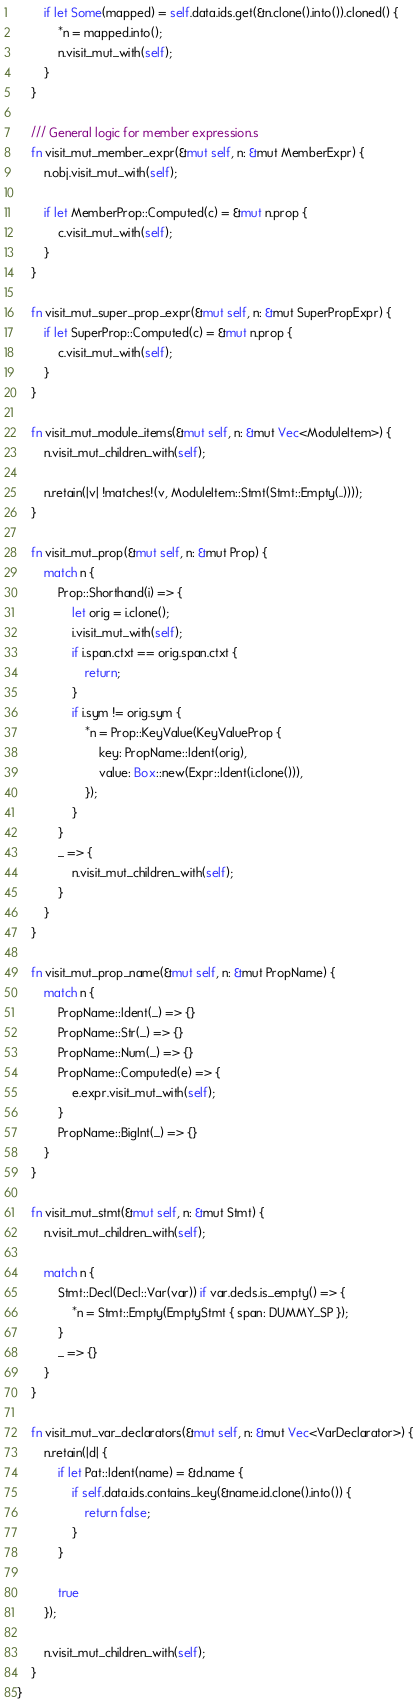<code> <loc_0><loc_0><loc_500><loc_500><_Rust_>        if let Some(mapped) = self.data.ids.get(&n.clone().into()).cloned() {
            *n = mapped.into();
            n.visit_mut_with(self);
        }
    }

    /// General logic for member expression.s
    fn visit_mut_member_expr(&mut self, n: &mut MemberExpr) {
        n.obj.visit_mut_with(self);

        if let MemberProp::Computed(c) = &mut n.prop {
            c.visit_mut_with(self);
        }
    }

    fn visit_mut_super_prop_expr(&mut self, n: &mut SuperPropExpr) {
        if let SuperProp::Computed(c) = &mut n.prop {
            c.visit_mut_with(self);
        }
    }

    fn visit_mut_module_items(&mut self, n: &mut Vec<ModuleItem>) {
        n.visit_mut_children_with(self);

        n.retain(|v| !matches!(v, ModuleItem::Stmt(Stmt::Empty(..))));
    }

    fn visit_mut_prop(&mut self, n: &mut Prop) {
        match n {
            Prop::Shorthand(i) => {
                let orig = i.clone();
                i.visit_mut_with(self);
                if i.span.ctxt == orig.span.ctxt {
                    return;
                }
                if i.sym != orig.sym {
                    *n = Prop::KeyValue(KeyValueProp {
                        key: PropName::Ident(orig),
                        value: Box::new(Expr::Ident(i.clone())),
                    });
                }
            }
            _ => {
                n.visit_mut_children_with(self);
            }
        }
    }

    fn visit_mut_prop_name(&mut self, n: &mut PropName) {
        match n {
            PropName::Ident(_) => {}
            PropName::Str(_) => {}
            PropName::Num(_) => {}
            PropName::Computed(e) => {
                e.expr.visit_mut_with(self);
            }
            PropName::BigInt(_) => {}
        }
    }

    fn visit_mut_stmt(&mut self, n: &mut Stmt) {
        n.visit_mut_children_with(self);

        match n {
            Stmt::Decl(Decl::Var(var)) if var.decls.is_empty() => {
                *n = Stmt::Empty(EmptyStmt { span: DUMMY_SP });
            }
            _ => {}
        }
    }

    fn visit_mut_var_declarators(&mut self, n: &mut Vec<VarDeclarator>) {
        n.retain(|d| {
            if let Pat::Ident(name) = &d.name {
                if self.data.ids.contains_key(&name.id.clone().into()) {
                    return false;
                }
            }

            true
        });

        n.visit_mut_children_with(self);
    }
}
</code> 